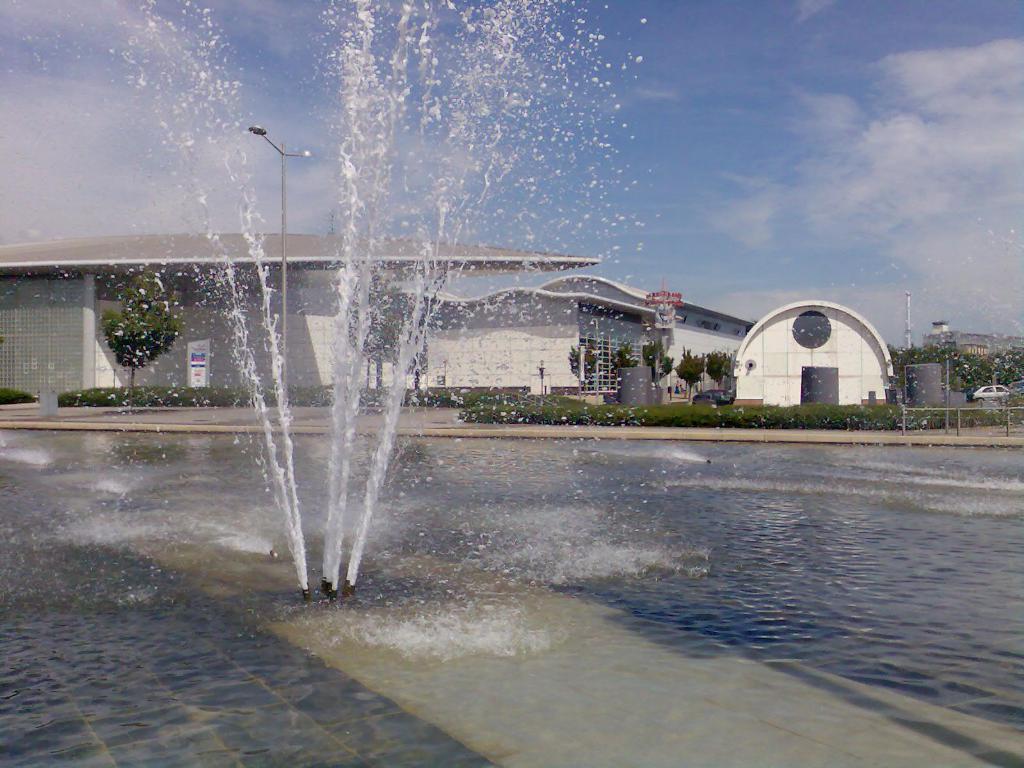Describe this image in one or two sentences. In the background we can see the sky. In this picture we can see trees, houses, water fountain, board, plants, railing and few objects. On the right side of the picture we can see a vehicle. 